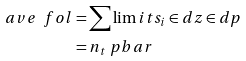Convert formula to latex. <formula><loc_0><loc_0><loc_500><loc_500>\ a v e { \ f o l } & = \sum \lim i t s _ { i } \in d z \in d p \\ & = n _ { t } \ p b a r</formula> 